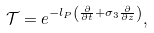Convert formula to latex. <formula><loc_0><loc_0><loc_500><loc_500>\mathcal { T } = e ^ { - l _ { P } \left ( \frac { \partial } { \partial t } + \sigma _ { 3 } \frac { \partial } { \partial z } \right ) } ,</formula> 